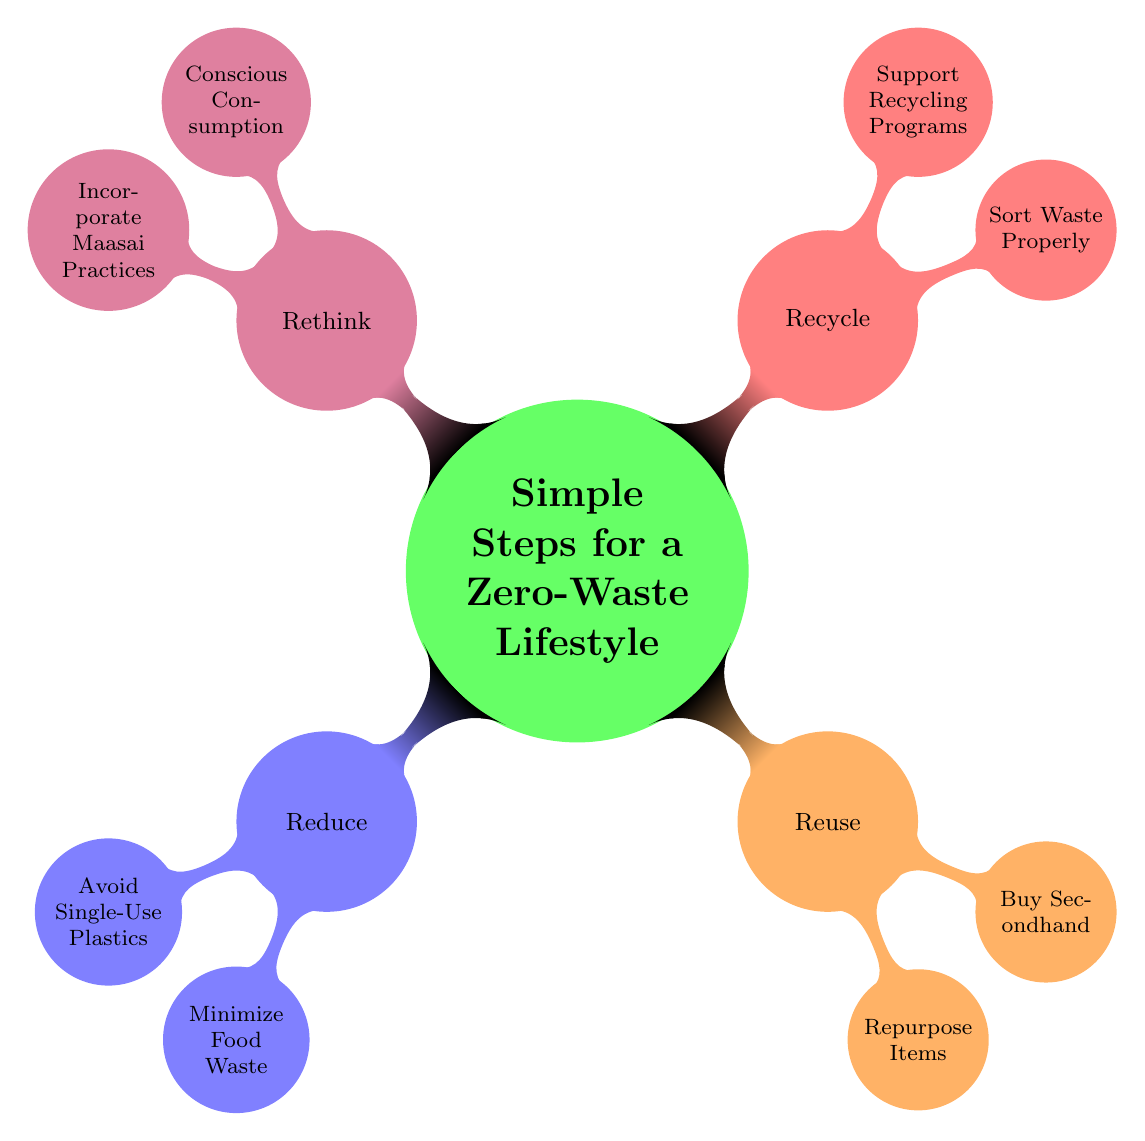What is the main idea of the diagram? The main idea is stated clearly at the center of the mind map, which is "Simple Steps for a Zero-Waste Lifestyle".
Answer: Simple Steps for a Zero-Waste Lifestyle How many branches are there in the diagram? The diagram contains four branches: Reduce, Reuse, Recycle, and Rethink, which can be counted directly.
Answer: 4 What is a sub-branch of the "Reduce" branch? "Avoid Single-Use Plastics" and "Minimize Food Waste" are both listed as sub-branches under "Reduce". By looking at the "Reduce" node directly, one can identify its sub-branches.
Answer: Avoid Single-Use Plastics What examples are given under "Reuse"? The sub-branch "Repurpose Items" includes examples such as using glass jars for storage and turning old clothes into cleaning rags. To find this, you look under the "Reuse" branch and read its corresponding examples.
Answer: Use glass jars for storage Which branch includes the concept of "Conscious Consumption"? "Conscious Consumption" is a sub-branch that falls under the "Rethink" branch. By tracing the branches, "Rethink" leads to "Conscious Consumption".
Answer: Rethink What is one action suggested to minimize food waste? The "Minimize Food Waste" sub-branch lists "Plan meals" as one of the suggested actions. This can be found directly under the "Reduce" branch.
Answer: Plan meals Which two practices can be incorporated from Maasai culture? The sub-branch "Incorporate Maasai Practices" provides two examples: learning about sustainable livestock practices and understanding the Maasai's minimalistic approach. Both examples are listed directly beneath this sub-branch.
Answer: Learn about sustainable livestock practices and understand Maasai's minimalistic approach What is a recommended action under "Support Recycling Programs"? "Participate in community recycling initiatives" is a listed example under this sub-branch. To answer this, one needs to refer to the "Support Recycling Programs" sub-branch under "Recycle".
Answer: Participate in community recycling initiatives 